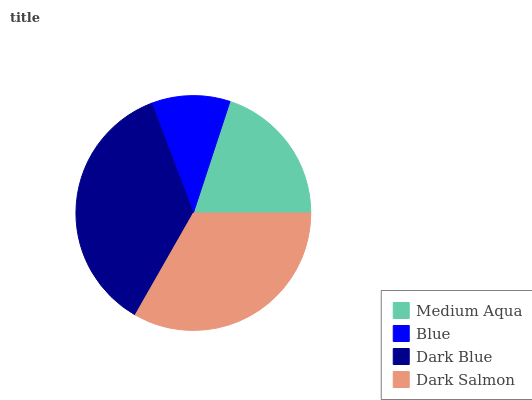Is Blue the minimum?
Answer yes or no. Yes. Is Dark Blue the maximum?
Answer yes or no. Yes. Is Dark Blue the minimum?
Answer yes or no. No. Is Blue the maximum?
Answer yes or no. No. Is Dark Blue greater than Blue?
Answer yes or no. Yes. Is Blue less than Dark Blue?
Answer yes or no. Yes. Is Blue greater than Dark Blue?
Answer yes or no. No. Is Dark Blue less than Blue?
Answer yes or no. No. Is Dark Salmon the high median?
Answer yes or no. Yes. Is Medium Aqua the low median?
Answer yes or no. Yes. Is Dark Blue the high median?
Answer yes or no. No. Is Blue the low median?
Answer yes or no. No. 